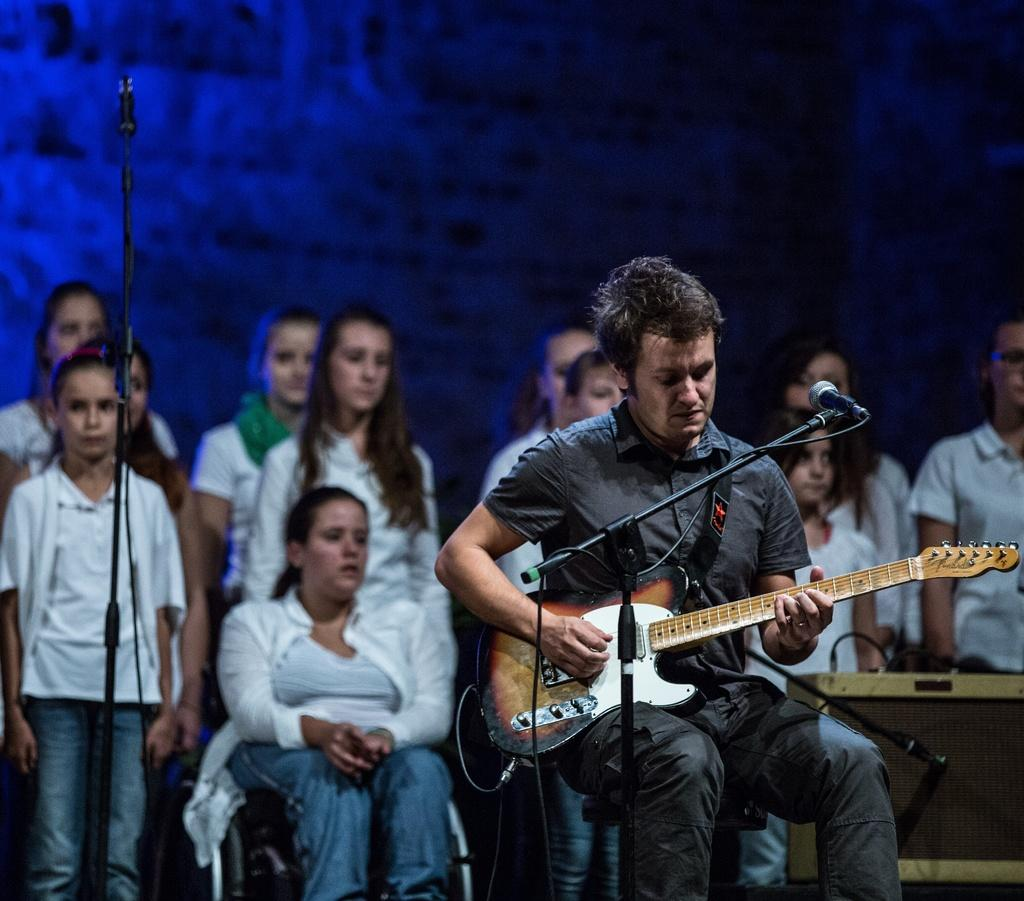What is the person in the image doing? The person is sitting on a chair and holding a guitar. What object is in front of the person? There is a microphone in front of the person. Can you describe the background of the image? There are people standing in the background and a wall is visible. What type of canvas is the person painting in the image? There is no canvas or painting activity present in the image. Can you tell me what the grandfather is doing in the image? There is no mention of a grandfather or any elderly person in the image. 